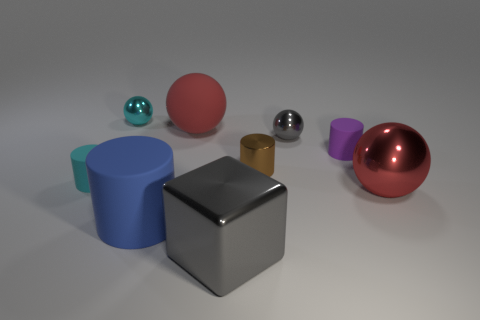Is the number of tiny brown metal cylinders that are to the right of the small brown cylinder less than the number of big matte objects to the right of the red metallic sphere?
Offer a terse response. No. There is a metallic cube; are there any tiny cyan metal things to the right of it?
Your answer should be compact. No. There is a large matte thing that is in front of the tiny matte cylinder that is on the right side of the large rubber cylinder; are there any tiny cyan metal balls right of it?
Ensure brevity in your answer.  No. There is a tiny cyan object that is in front of the purple object; does it have the same shape as the tiny gray shiny thing?
Ensure brevity in your answer.  No. What color is the big ball that is the same material as the small brown thing?
Make the answer very short. Red. How many large blue cylinders are the same material as the tiny brown cylinder?
Your response must be concise. 0. There is a tiny matte cylinder that is to the left of the cyan object behind the tiny purple cylinder on the right side of the small gray metallic object; what color is it?
Provide a short and direct response. Cyan. Do the blue cylinder and the cyan cylinder have the same size?
Provide a short and direct response. No. Are there any other things that are the same shape as the red matte thing?
Keep it short and to the point. Yes. What number of things are either small objects that are in front of the large rubber sphere or gray shiny spheres?
Your answer should be very brief. 4. 